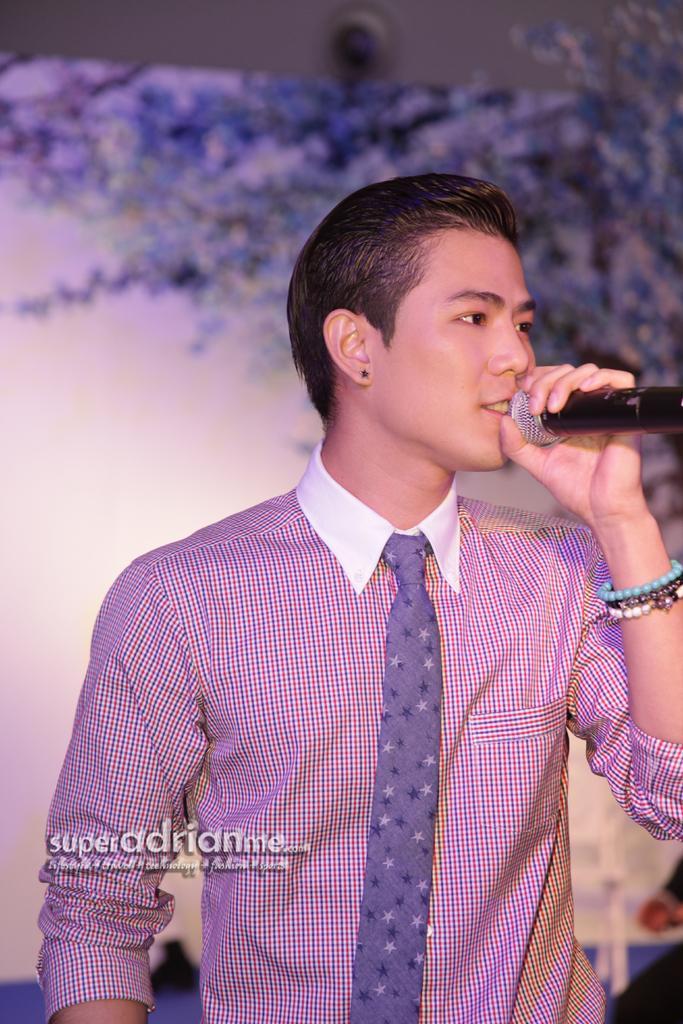Describe this image in one or two sentences. A man wearing shirt and tie is singing with mic in his hand. 